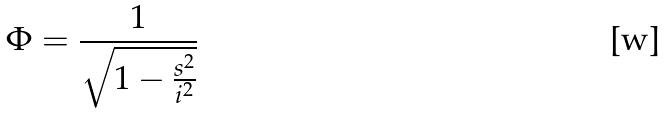Convert formula to latex. <formula><loc_0><loc_0><loc_500><loc_500>\Phi = \frac { 1 } { \sqrt { 1 - \frac { s ^ { 2 } } { i ^ { 2 } } } }</formula> 